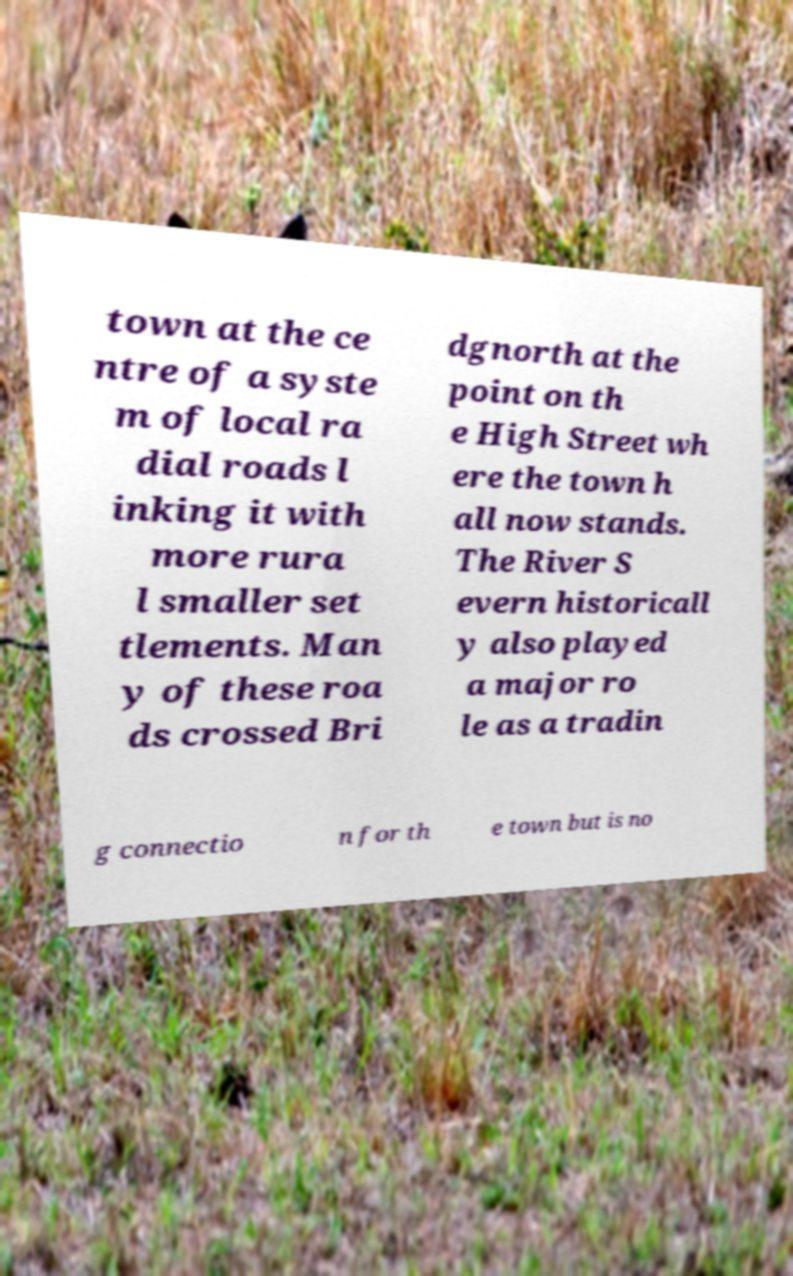I need the written content from this picture converted into text. Can you do that? town at the ce ntre of a syste m of local ra dial roads l inking it with more rura l smaller set tlements. Man y of these roa ds crossed Bri dgnorth at the point on th e High Street wh ere the town h all now stands. The River S evern historicall y also played a major ro le as a tradin g connectio n for th e town but is no 